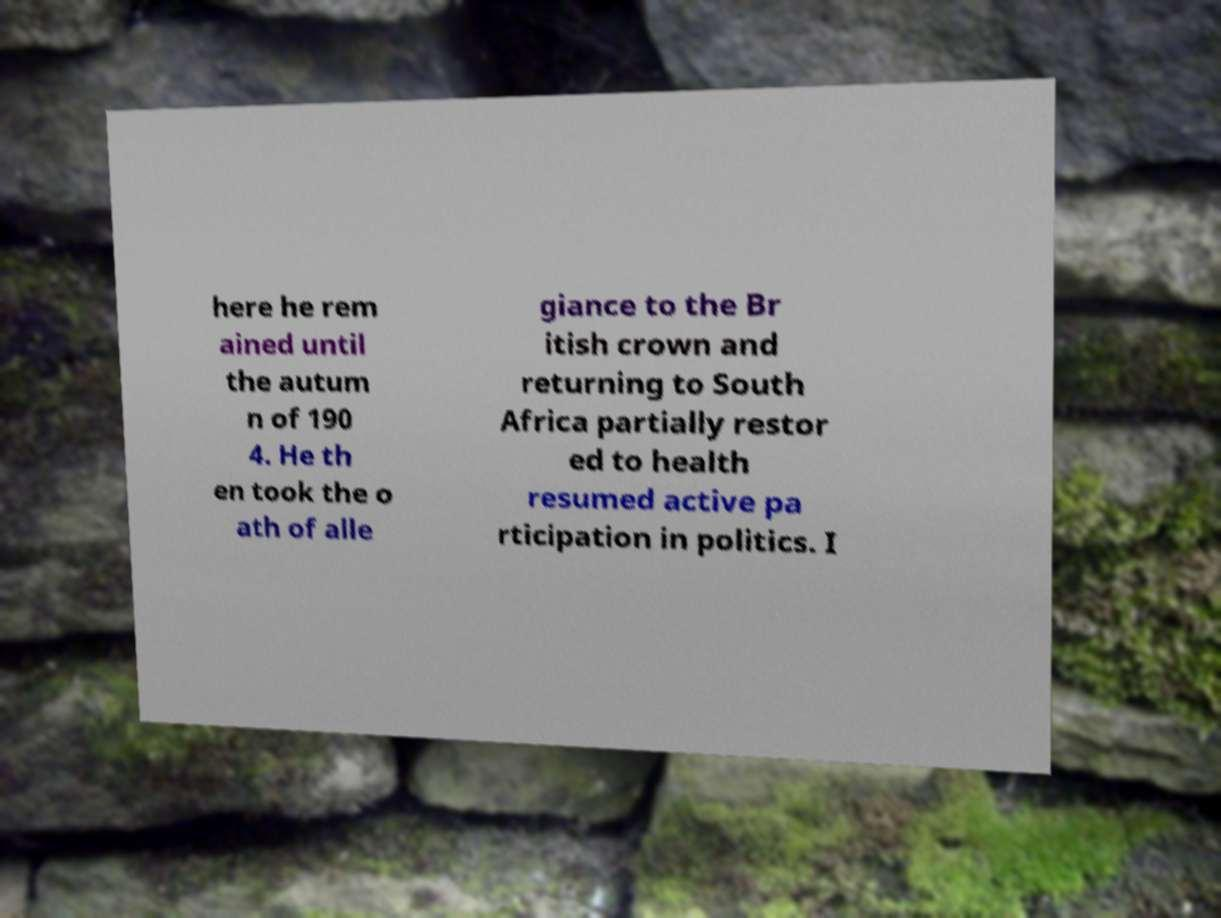Can you accurately transcribe the text from the provided image for me? here he rem ained until the autum n of 190 4. He th en took the o ath of alle giance to the Br itish crown and returning to South Africa partially restor ed to health resumed active pa rticipation in politics. I 